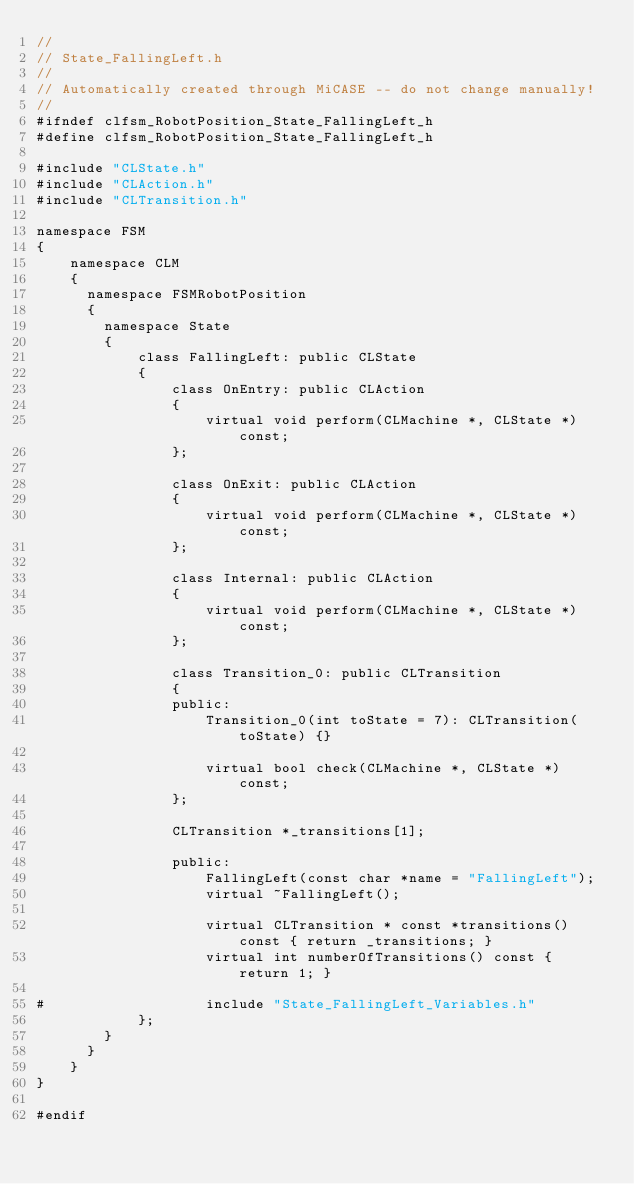<code> <loc_0><loc_0><loc_500><loc_500><_C_>//
// State_FallingLeft.h
//
// Automatically created through MiCASE -- do not change manually!
//
#ifndef clfsm_RobotPosition_State_FallingLeft_h
#define clfsm_RobotPosition_State_FallingLeft_h

#include "CLState.h"
#include "CLAction.h"
#include "CLTransition.h"

namespace FSM
{
    namespace CLM
    {
      namespace FSMRobotPosition
      {
        namespace State
        {
            class FallingLeft: public CLState
            {
                class OnEntry: public CLAction
                {
                    virtual void perform(CLMachine *, CLState *) const;
                };

                class OnExit: public CLAction
                {
                    virtual void perform(CLMachine *, CLState *) const;
                };

                class Internal: public CLAction
                {
                    virtual void perform(CLMachine *, CLState *) const;
                };

                class Transition_0: public CLTransition
                {
                public:
                    Transition_0(int toState = 7): CLTransition(toState) {}

                    virtual bool check(CLMachine *, CLState *) const;
                };

                CLTransition *_transitions[1];

                public:
                    FallingLeft(const char *name = "FallingLeft");
                    virtual ~FallingLeft();

                    virtual CLTransition * const *transitions() const { return _transitions; }
                    virtual int numberOfTransitions() const { return 1; }

#                   include "State_FallingLeft_Variables.h"
            };
        }
      }
    }
}

#endif
</code> 